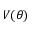<formula> <loc_0><loc_0><loc_500><loc_500>V ( \theta )</formula> 